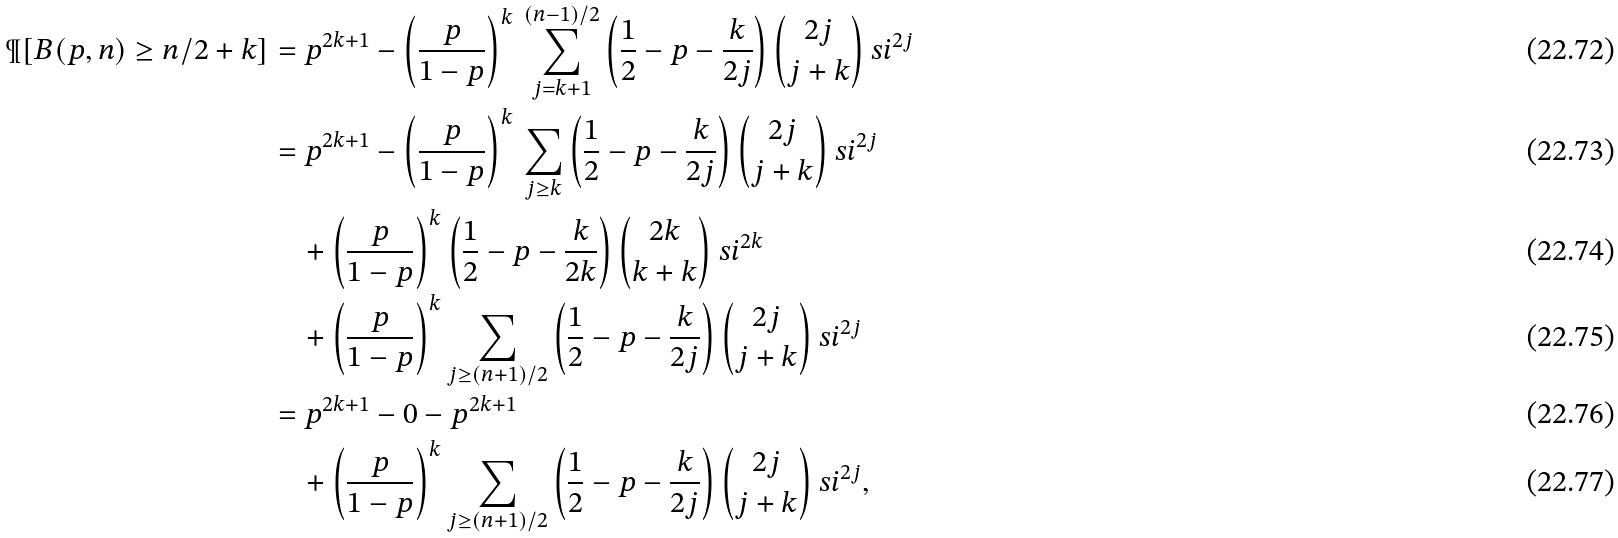<formula> <loc_0><loc_0><loc_500><loc_500>\P [ B ( p , n ) \geq n / 2 + k ] & = p ^ { 2 k + 1 } - \left ( \frac { p } { 1 - p } \right ) ^ { k } \, \sum _ { j = k + 1 } ^ { ( n - 1 ) / 2 } \left ( \frac { 1 } { 2 } - p - \frac { k } { 2 j } \right ) \binom { 2 j } { j + k } \ s i ^ { 2 j } \\ & = p ^ { 2 k + 1 } - \left ( \frac { p } { 1 - p } \right ) ^ { k } \, \sum _ { j \geq k } \left ( \frac { 1 } { 2 } - p - \frac { k } { 2 j } \right ) \binom { 2 j } { j + k } \ s i ^ { 2 j } \\ & \quad + \left ( \frac { p } { 1 - p } \right ) ^ { k } \left ( \frac { 1 } { 2 } - p - \frac { k } { 2 k } \right ) \binom { 2 k } { k + k } \ s i ^ { 2 k } \\ & \quad + \left ( \frac { p } { 1 - p } \right ) ^ { k } \sum _ { j \geq ( n + 1 ) / 2 } \left ( \frac { 1 } { 2 } - p - \frac { k } { 2 j } \right ) \binom { 2 j } { j + k } \ s i ^ { 2 j } \\ & = p ^ { 2 k + 1 } - 0 - p ^ { 2 k + 1 } \\ & \quad + \left ( \frac { p } { 1 - p } \right ) ^ { k } \sum _ { j \geq ( n + 1 ) / 2 } \left ( \frac { 1 } { 2 } - p - \frac { k } { 2 j } \right ) \binom { 2 j } { j + k } \ s i ^ { 2 j } ,</formula> 